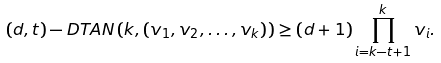Convert formula to latex. <formula><loc_0><loc_0><loc_500><loc_500>( d , t ) - D T A N \left ( k , ( v _ { 1 } , v _ { 2 } , \dots , v _ { k } ) \right ) \geq ( d + 1 ) \prod _ { i = k - t + 1 } ^ { k } v _ { i } .</formula> 